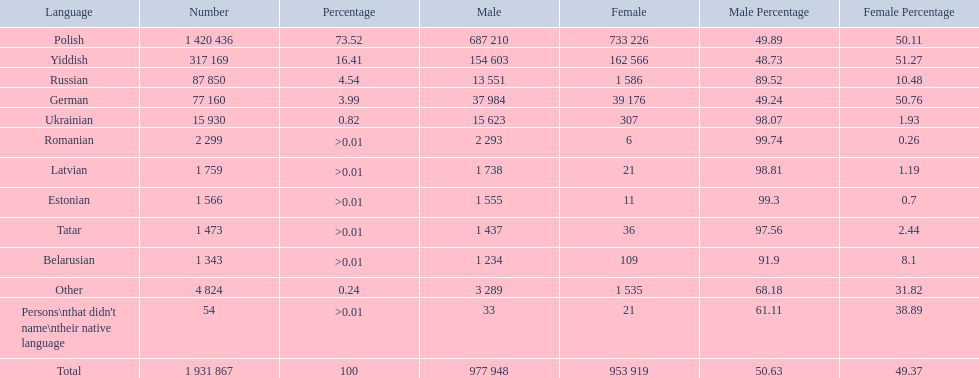Which languages had percentages of >0.01? Romanian, Latvian, Estonian, Tatar, Belarusian. What was the top language? Romanian. 